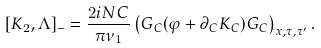<formula> <loc_0><loc_0><loc_500><loc_500>[ K _ { 2 } , \Lambda ] _ { - } = \frac { 2 i N C } { \pi \nu _ { 1 } } \left ( G _ { C } ( \varphi + \partial _ { C } K _ { C } ) G _ { C } \right ) _ { x , \tau , \tau ^ { \prime } } .</formula> 